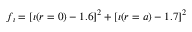Convert formula to latex. <formula><loc_0><loc_0><loc_500><loc_500>f _ { \iota } = [ \iota ( r = 0 ) - 1 . 6 ] ^ { 2 } + [ \iota ( r = a ) - 1 . 7 ] ^ { 2 }</formula> 